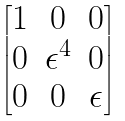Convert formula to latex. <formula><loc_0><loc_0><loc_500><loc_500>\begin{bmatrix} 1 & 0 & 0 \\ 0 & \epsilon ^ { 4 } & 0 \\ 0 & 0 & \epsilon \\ \end{bmatrix}</formula> 